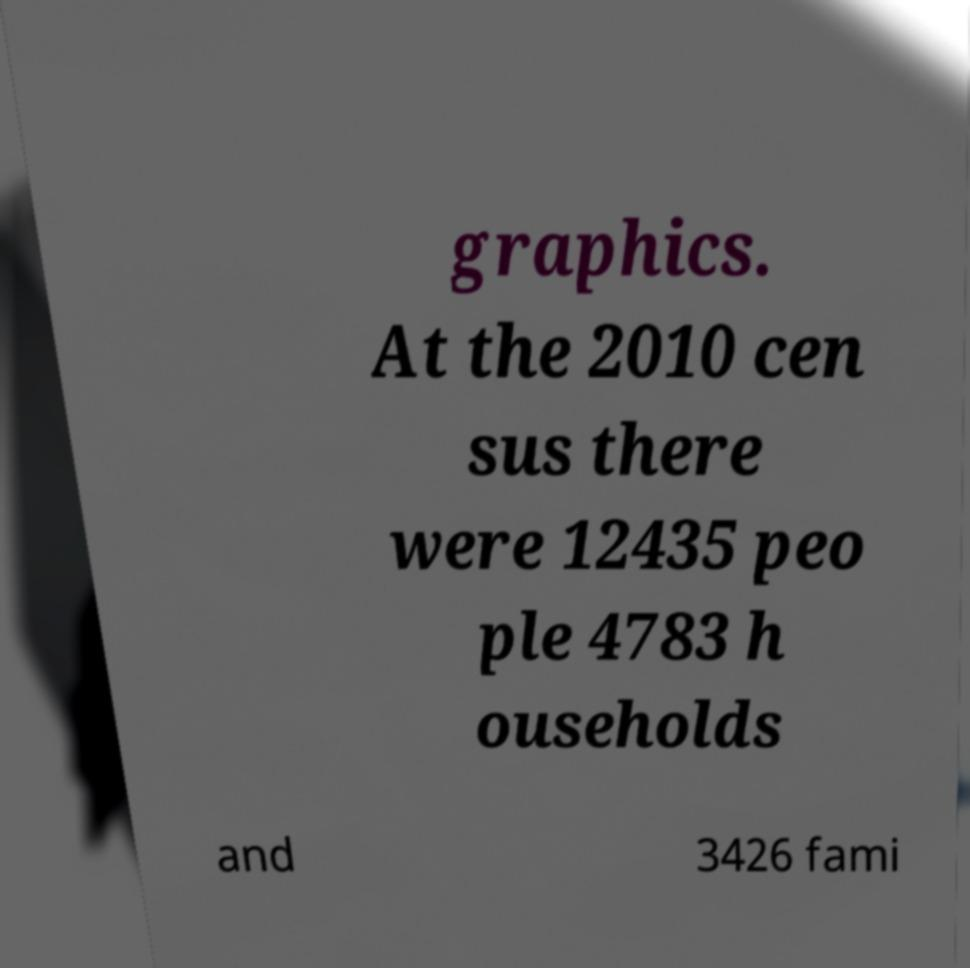Can you read and provide the text displayed in the image?This photo seems to have some interesting text. Can you extract and type it out for me? graphics. At the 2010 cen sus there were 12435 peo ple 4783 h ouseholds and 3426 fami 